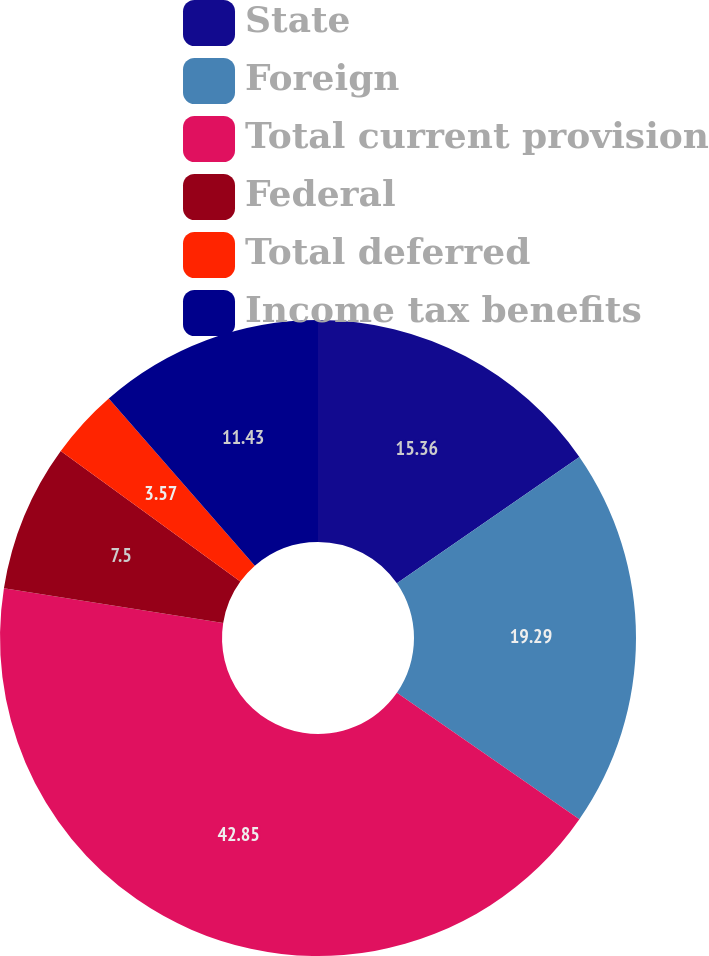Convert chart. <chart><loc_0><loc_0><loc_500><loc_500><pie_chart><fcel>State<fcel>Foreign<fcel>Total current provision<fcel>Federal<fcel>Total deferred<fcel>Income tax benefits<nl><fcel>15.36%<fcel>19.29%<fcel>42.86%<fcel>7.5%<fcel>3.57%<fcel>11.43%<nl></chart> 